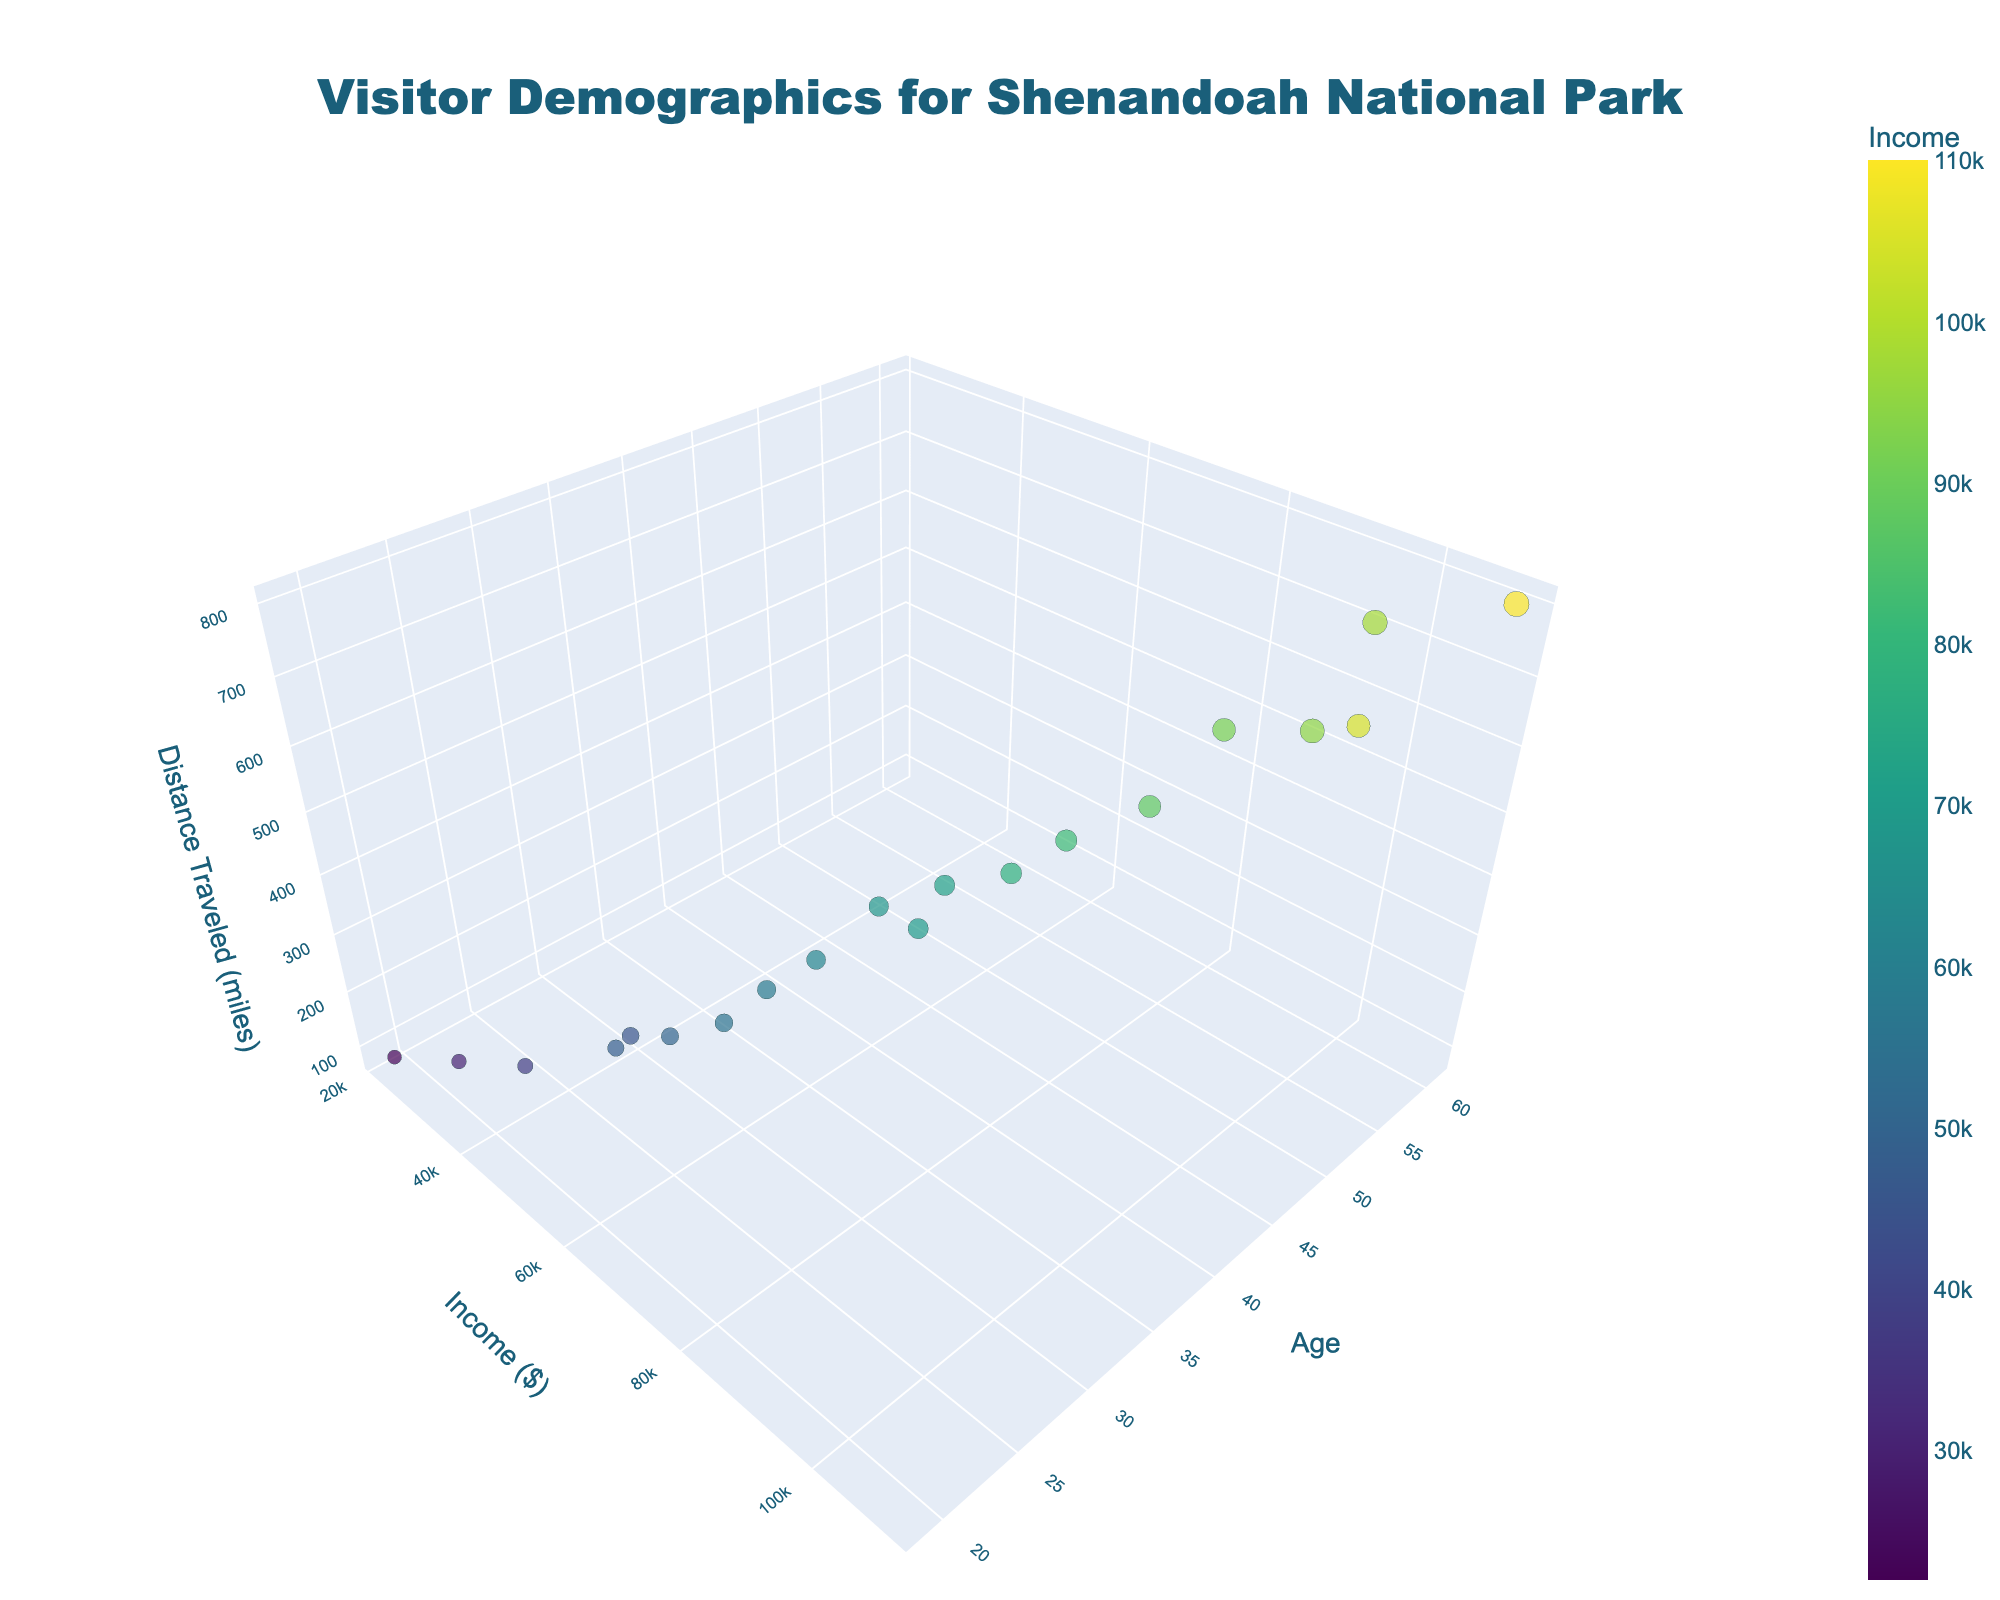What's the title of the figure? The title is usually located at the top of the figure. Look at the top-center to find the name or description summarizing the content of the plot.
Answer: Visitor Demographics for Shenandoah National Park How many data points are shown in the plot? Count the individual markers present in the 3D space of the scatter plot to determine the total number of data points.
Answer: 20 Which axis represents age? Identify the label on each axis. The axis that has "Age" as its title will be the one representing age.
Answer: The x-axis Which visitor has the highest income? Look for the data point with the highest value on the y-axis (income axis) and check its corresponding hover data to identify the visitor's age.
Answer: The visitor aged 61 What is the average distance traveled by visitors with an income greater than $60,000? Identify all data points where the income (y-axis value) is greater than $60,000. Sum the corresponding distances traveled (z-axis values) and divide by the number of such data points.
Answer: 482.14 miles Which age group has the widest range of distances traveled? Compare the range of distances (z-axis values) for distinct groups of ages. Look for the age group where the difference between the maximum and minimum distance is the greatest.
Answer: Ages between 40-61 Is there a visible correlation between age and distance traveled? Observe the scatter plot to see if there's a trend or consistent pattern as age (x-axis) increases, correlating with changes in distance traveled (z-axis).
Answer: Generally, older visitors travel longer distances Which visitor group has the most diverse income levels? Analyze the spread of y-axis values (income) within different ranges of age or distance traveled to determine which group shows the widest variation.
Answer: Ages between 40-61 In which income category do visitors tend to travel longer distances? Observe the data points with the longest distances traveled (highest z-axis values) and note the corresponding income values (y-axis).
Answer: Income > $90,000 What's the relationship between age and income among the visitors? Observe the plot to see if income (y-axis) values increase, decrease, or show no pattern with increasing age (x-axis).
Answer: Generally, income increases with age 